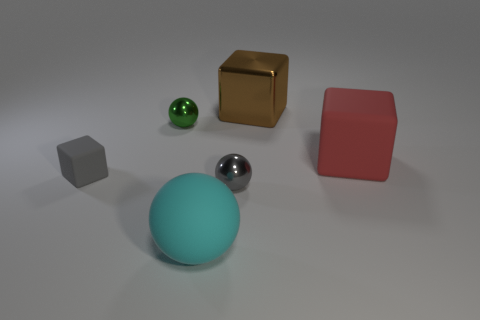Does the large cyan rubber thing have the same shape as the green object?
Your answer should be very brief. Yes. There is a tiny ball behind the small shiny sphere to the right of the small green sphere; what is it made of?
Your response must be concise. Metal. There is a object that is the same color as the tiny cube; what is it made of?
Provide a short and direct response. Metal. Does the cyan matte thing have the same size as the gray matte object?
Make the answer very short. No. There is a tiny object behind the red rubber cube; is there a big red rubber thing that is to the left of it?
Provide a succinct answer. No. What shape is the large thing that is to the right of the metallic cube?
Keep it short and to the point. Cube. What number of large rubber blocks are in front of the rubber object that is on the right side of the cube behind the tiny green metallic sphere?
Keep it short and to the point. 0. There is a brown block; is its size the same as the rubber object on the right side of the brown object?
Give a very brief answer. Yes. There is a matte block that is left of the small shiny ball behind the tiny gray rubber block; what is its size?
Provide a succinct answer. Small. How many tiny green cubes are made of the same material as the cyan sphere?
Provide a short and direct response. 0. 